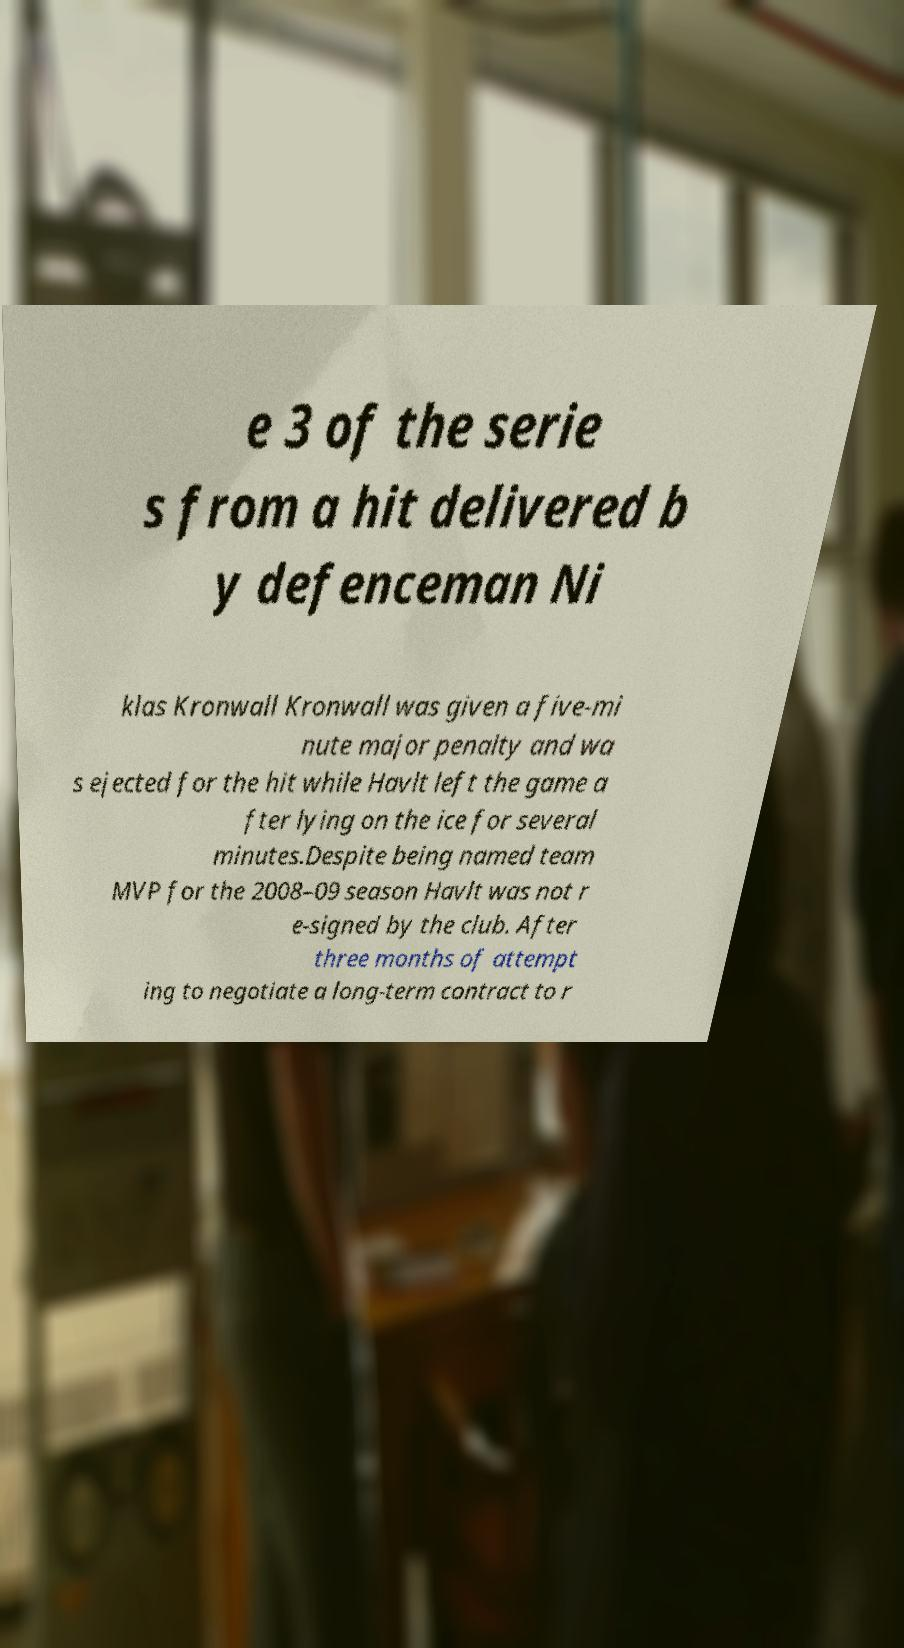Please read and relay the text visible in this image. What does it say? e 3 of the serie s from a hit delivered b y defenceman Ni klas Kronwall Kronwall was given a five-mi nute major penalty and wa s ejected for the hit while Havlt left the game a fter lying on the ice for several minutes.Despite being named team MVP for the 2008–09 season Havlt was not r e-signed by the club. After three months of attempt ing to negotiate a long-term contract to r 